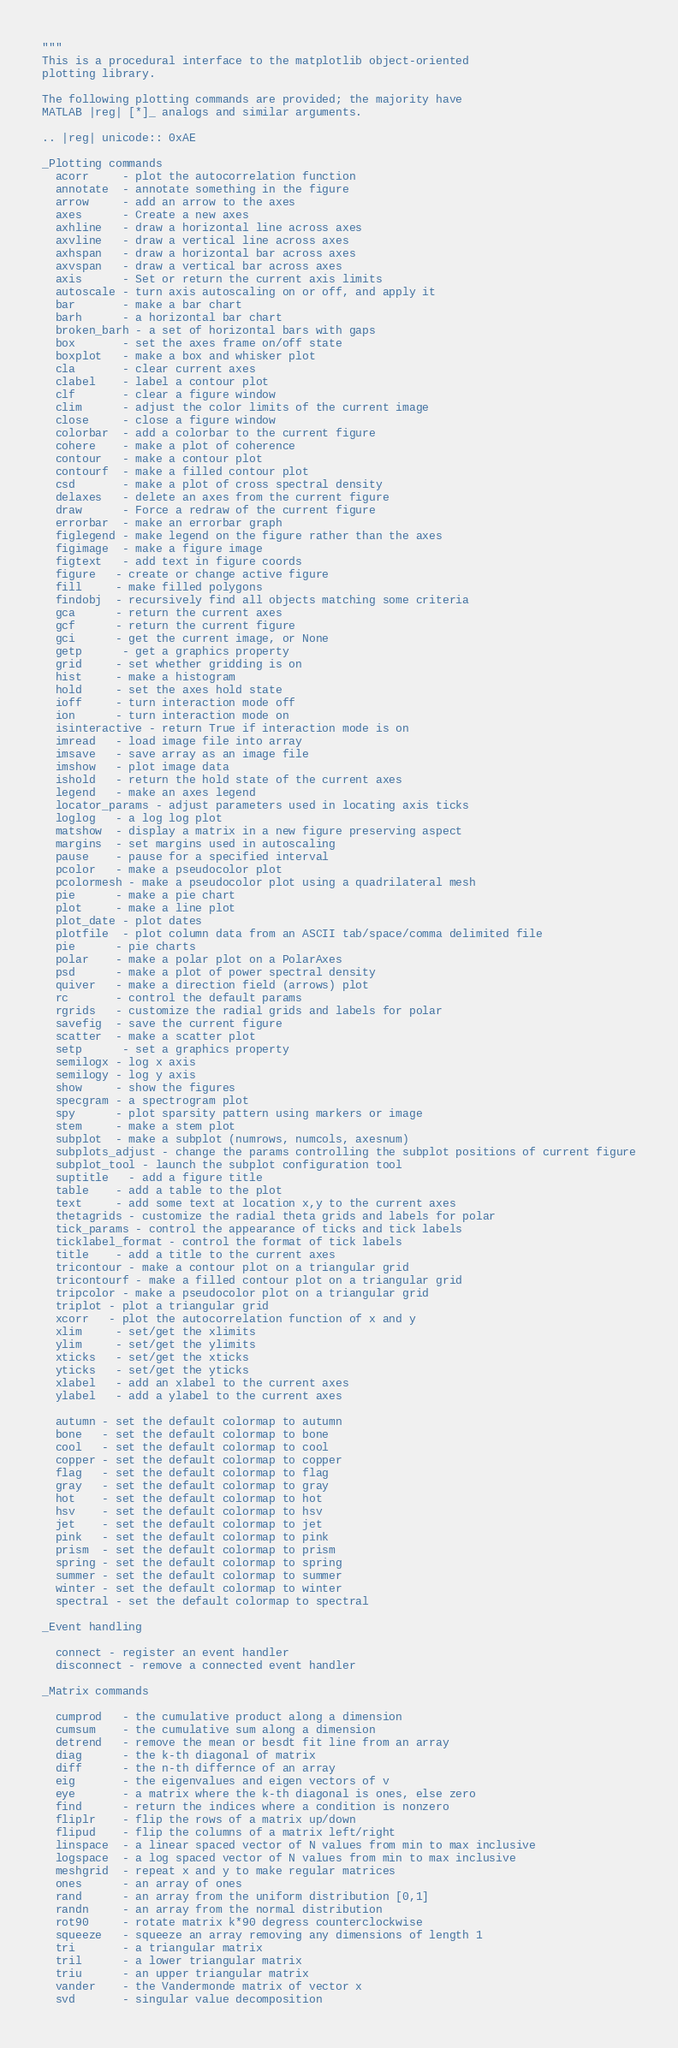<code> <loc_0><loc_0><loc_500><loc_500><_Python_>"""
This is a procedural interface to the matplotlib object-oriented
plotting library.

The following plotting commands are provided; the majority have
MATLAB |reg| [*]_ analogs and similar arguments.

.. |reg| unicode:: 0xAE

_Plotting commands
  acorr     - plot the autocorrelation function
  annotate  - annotate something in the figure
  arrow     - add an arrow to the axes
  axes      - Create a new axes
  axhline   - draw a horizontal line across axes
  axvline   - draw a vertical line across axes
  axhspan   - draw a horizontal bar across axes
  axvspan   - draw a vertical bar across axes
  axis      - Set or return the current axis limits
  autoscale - turn axis autoscaling on or off, and apply it
  bar       - make a bar chart
  barh      - a horizontal bar chart
  broken_barh - a set of horizontal bars with gaps
  box       - set the axes frame on/off state
  boxplot   - make a box and whisker plot
  cla       - clear current axes
  clabel    - label a contour plot
  clf       - clear a figure window
  clim      - adjust the color limits of the current image
  close     - close a figure window
  colorbar  - add a colorbar to the current figure
  cohere    - make a plot of coherence
  contour   - make a contour plot
  contourf  - make a filled contour plot
  csd       - make a plot of cross spectral density
  delaxes   - delete an axes from the current figure
  draw      - Force a redraw of the current figure
  errorbar  - make an errorbar graph
  figlegend - make legend on the figure rather than the axes
  figimage  - make a figure image
  figtext   - add text in figure coords
  figure   - create or change active figure
  fill     - make filled polygons
  findobj  - recursively find all objects matching some criteria
  gca      - return the current axes
  gcf      - return the current figure
  gci      - get the current image, or None
  getp      - get a graphics property
  grid     - set whether gridding is on
  hist     - make a histogram
  hold     - set the axes hold state
  ioff     - turn interaction mode off
  ion      - turn interaction mode on
  isinteractive - return True if interaction mode is on
  imread   - load image file into array
  imsave   - save array as an image file
  imshow   - plot image data
  ishold   - return the hold state of the current axes
  legend   - make an axes legend
  locator_params - adjust parameters used in locating axis ticks
  loglog   - a log log plot
  matshow  - display a matrix in a new figure preserving aspect
  margins  - set margins used in autoscaling
  pause    - pause for a specified interval
  pcolor   - make a pseudocolor plot
  pcolormesh - make a pseudocolor plot using a quadrilateral mesh
  pie      - make a pie chart
  plot     - make a line plot
  plot_date - plot dates
  plotfile  - plot column data from an ASCII tab/space/comma delimited file
  pie      - pie charts
  polar    - make a polar plot on a PolarAxes
  psd      - make a plot of power spectral density
  quiver   - make a direction field (arrows) plot
  rc       - control the default params
  rgrids   - customize the radial grids and labels for polar
  savefig  - save the current figure
  scatter  - make a scatter plot
  setp      - set a graphics property
  semilogx - log x axis
  semilogy - log y axis
  show     - show the figures
  specgram - a spectrogram plot
  spy      - plot sparsity pattern using markers or image
  stem     - make a stem plot
  subplot  - make a subplot (numrows, numcols, axesnum)
  subplots_adjust - change the params controlling the subplot positions of current figure
  subplot_tool - launch the subplot configuration tool
  suptitle   - add a figure title
  table    - add a table to the plot
  text     - add some text at location x,y to the current axes
  thetagrids - customize the radial theta grids and labels for polar
  tick_params - control the appearance of ticks and tick labels
  ticklabel_format - control the format of tick labels
  title    - add a title to the current axes
  tricontour - make a contour plot on a triangular grid
  tricontourf - make a filled contour plot on a triangular grid
  tripcolor - make a pseudocolor plot on a triangular grid
  triplot - plot a triangular grid
  xcorr   - plot the autocorrelation function of x and y
  xlim     - set/get the xlimits
  ylim     - set/get the ylimits
  xticks   - set/get the xticks
  yticks   - set/get the yticks
  xlabel   - add an xlabel to the current axes
  ylabel   - add a ylabel to the current axes

  autumn - set the default colormap to autumn
  bone   - set the default colormap to bone
  cool   - set the default colormap to cool
  copper - set the default colormap to copper
  flag   - set the default colormap to flag
  gray   - set the default colormap to gray
  hot    - set the default colormap to hot
  hsv    - set the default colormap to hsv
  jet    - set the default colormap to jet
  pink   - set the default colormap to pink
  prism  - set the default colormap to prism
  spring - set the default colormap to spring
  summer - set the default colormap to summer
  winter - set the default colormap to winter
  spectral - set the default colormap to spectral

_Event handling

  connect - register an event handler
  disconnect - remove a connected event handler

_Matrix commands

  cumprod   - the cumulative product along a dimension
  cumsum    - the cumulative sum along a dimension
  detrend   - remove the mean or besdt fit line from an array
  diag      - the k-th diagonal of matrix
  diff      - the n-th differnce of an array
  eig       - the eigenvalues and eigen vectors of v
  eye       - a matrix where the k-th diagonal is ones, else zero
  find      - return the indices where a condition is nonzero
  fliplr    - flip the rows of a matrix up/down
  flipud    - flip the columns of a matrix left/right
  linspace  - a linear spaced vector of N values from min to max inclusive
  logspace  - a log spaced vector of N values from min to max inclusive
  meshgrid  - repeat x and y to make regular matrices
  ones      - an array of ones
  rand      - an array from the uniform distribution [0,1]
  randn     - an array from the normal distribution
  rot90     - rotate matrix k*90 degress counterclockwise
  squeeze   - squeeze an array removing any dimensions of length 1
  tri       - a triangular matrix
  tril      - a lower triangular matrix
  triu      - an upper triangular matrix
  vander    - the Vandermonde matrix of vector x
  svd       - singular value decomposition</code> 